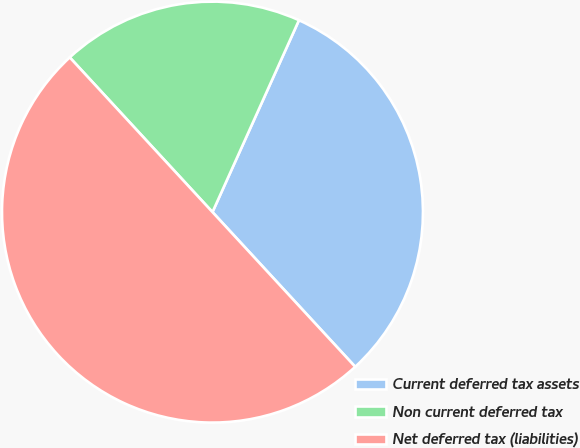Convert chart. <chart><loc_0><loc_0><loc_500><loc_500><pie_chart><fcel>Current deferred tax assets<fcel>Non current deferred tax<fcel>Net deferred tax (liabilities)<nl><fcel>31.4%<fcel>18.6%<fcel>50.0%<nl></chart> 